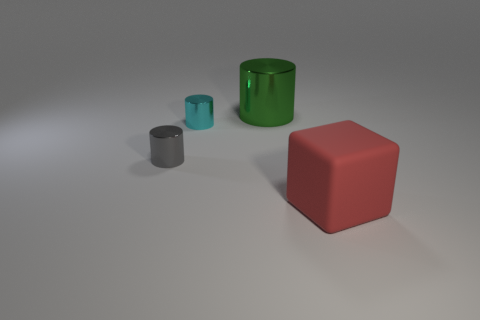What number of other objects are there of the same shape as the gray thing?
Offer a terse response. 2. There is a small thing in front of the tiny thing that is behind the tiny metallic cylinder in front of the small cyan metal cylinder; what is its shape?
Your answer should be very brief. Cylinder. How many objects are either purple cylinders or objects that are to the left of the red rubber thing?
Provide a succinct answer. 3. Is the shape of the large thing left of the large red thing the same as the thing that is on the right side of the green metal thing?
Keep it short and to the point. No. What number of objects are small cylinders or purple matte spheres?
Keep it short and to the point. 2. Is there any other thing that is the same material as the cyan thing?
Your response must be concise. Yes. Are there any big cyan matte cylinders?
Provide a short and direct response. No. Is the material of the object that is behind the cyan cylinder the same as the red block?
Provide a succinct answer. No. Is there another big gray metallic object that has the same shape as the big shiny object?
Your answer should be very brief. No. Are there an equal number of cyan things that are behind the gray shiny cylinder and tiny cyan matte cylinders?
Ensure brevity in your answer.  No. 